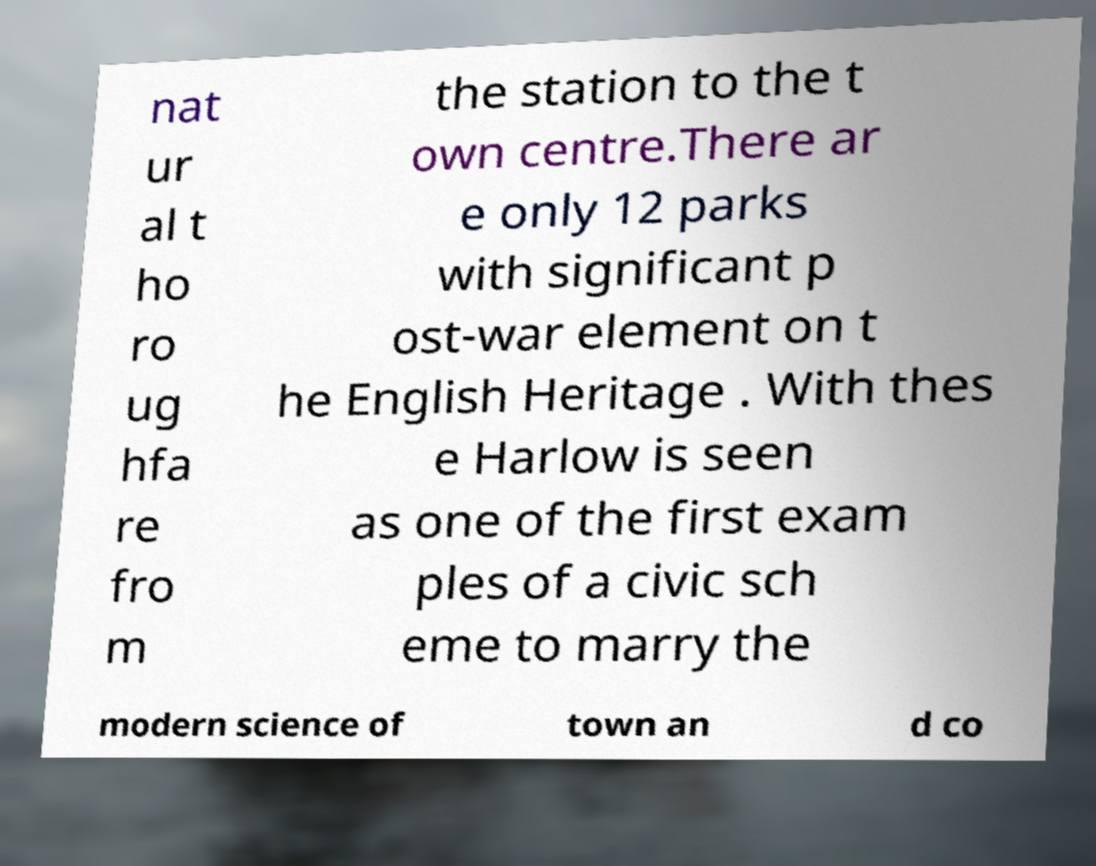What messages or text are displayed in this image? I need them in a readable, typed format. nat ur al t ho ro ug hfa re fro m the station to the t own centre.There ar e only 12 parks with significant p ost-war element on t he English Heritage . With thes e Harlow is seen as one of the first exam ples of a civic sch eme to marry the modern science of town an d co 